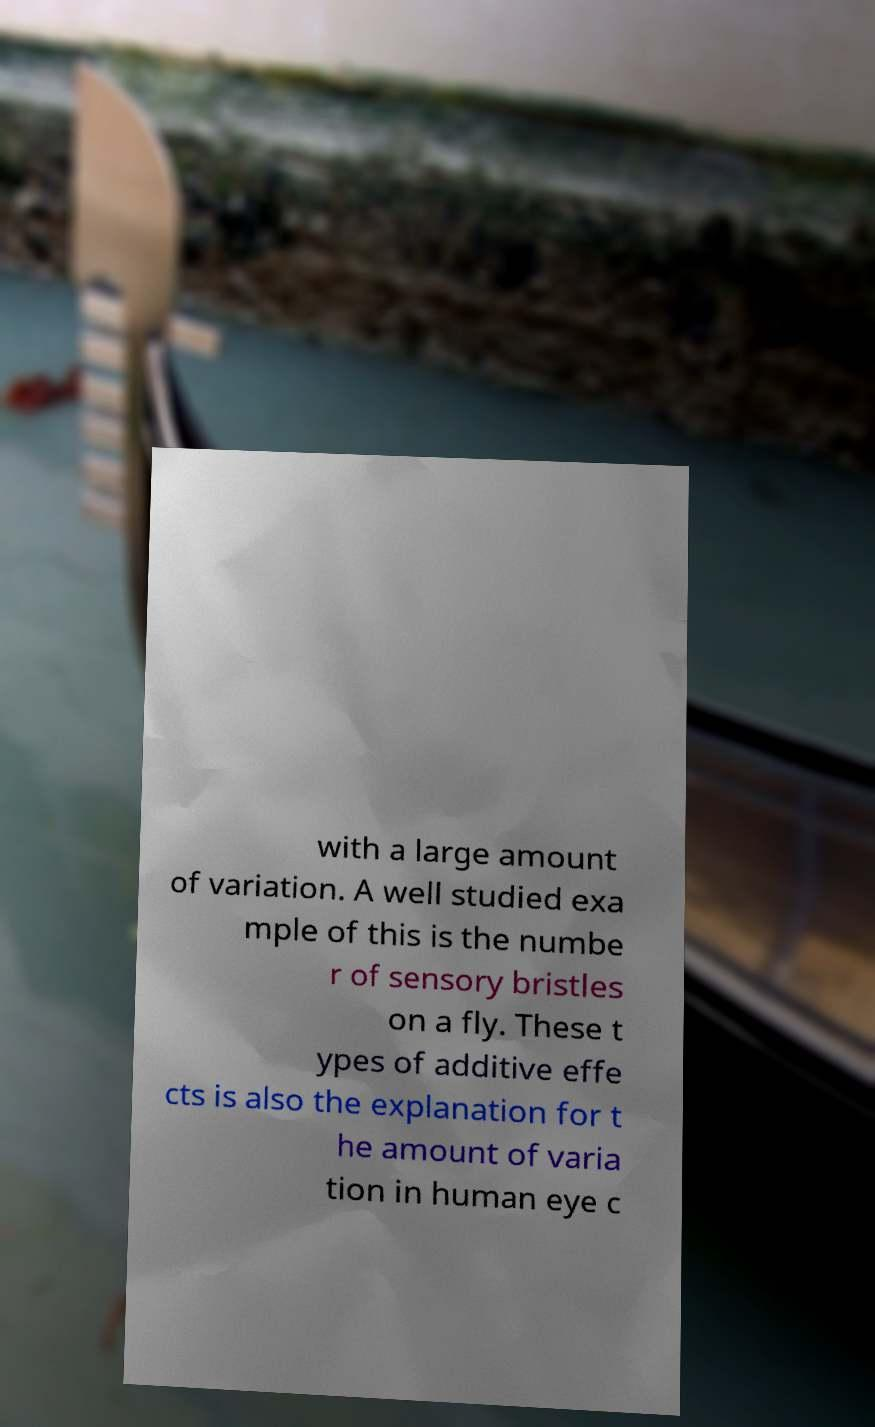Please identify and transcribe the text found in this image. with a large amount of variation. A well studied exa mple of this is the numbe r of sensory bristles on a fly. These t ypes of additive effe cts is also the explanation for t he amount of varia tion in human eye c 